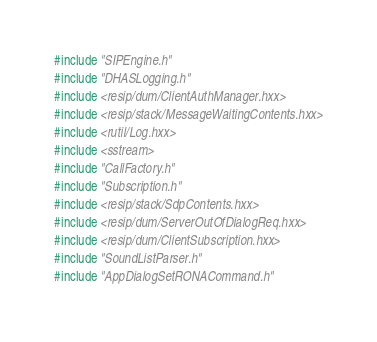<code> <loc_0><loc_0><loc_500><loc_500><_C++_>#include "SIPEngine.h"
#include "DHASLogging.h"
#include <resip/dum/ClientAuthManager.hxx>
#include <resip/stack/MessageWaitingContents.hxx>
#include <rutil/Log.hxx>
#include <sstream>
#include "CallFactory.h"
#include "Subscription.h"
#include <resip/stack/SdpContents.hxx>
#include <resip/dum/ServerOutOfDialogReq.hxx>
#include <resip/dum/ClientSubscription.hxx>
#include "SoundListParser.h"
#include "AppDialogSetRONACommand.h"</code> 